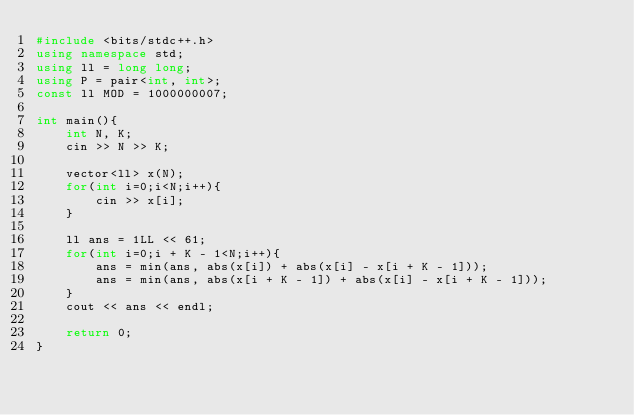<code> <loc_0><loc_0><loc_500><loc_500><_C++_>#include <bits/stdc++.h>
using namespace std;
using ll = long long;
using P = pair<int, int>;
const ll MOD = 1000000007;

int main(){
    int N, K;
    cin >> N >> K;

    vector<ll> x(N);
    for(int i=0;i<N;i++){
        cin >> x[i];
    }

    ll ans = 1LL << 61;
    for(int i=0;i + K - 1<N;i++){
        ans = min(ans, abs(x[i]) + abs(x[i] - x[i + K - 1]));
        ans = min(ans, abs(x[i + K - 1]) + abs(x[i] - x[i + K - 1]));
    }
    cout << ans << endl;

    return 0;
}</code> 